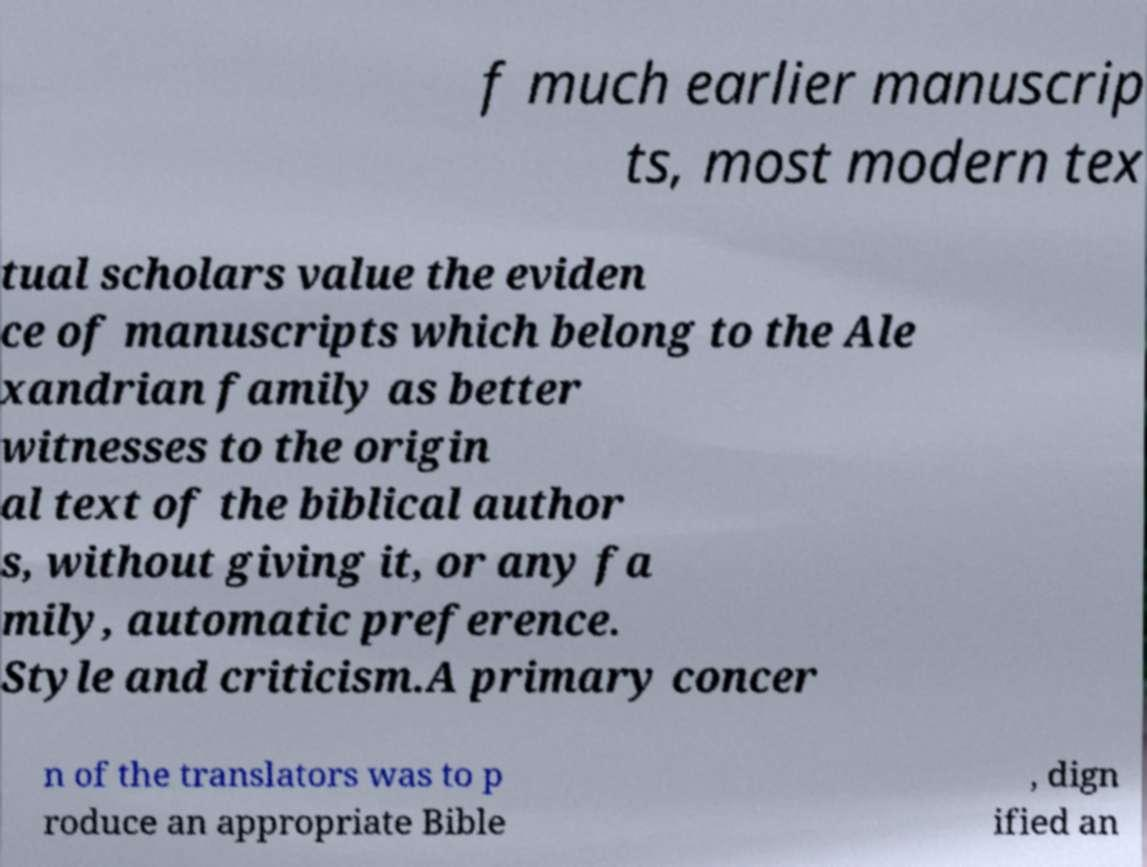What messages or text are displayed in this image? I need them in a readable, typed format. f much earlier manuscrip ts, most modern tex tual scholars value the eviden ce of manuscripts which belong to the Ale xandrian family as better witnesses to the origin al text of the biblical author s, without giving it, or any fa mily, automatic preference. Style and criticism.A primary concer n of the translators was to p roduce an appropriate Bible , dign ified an 